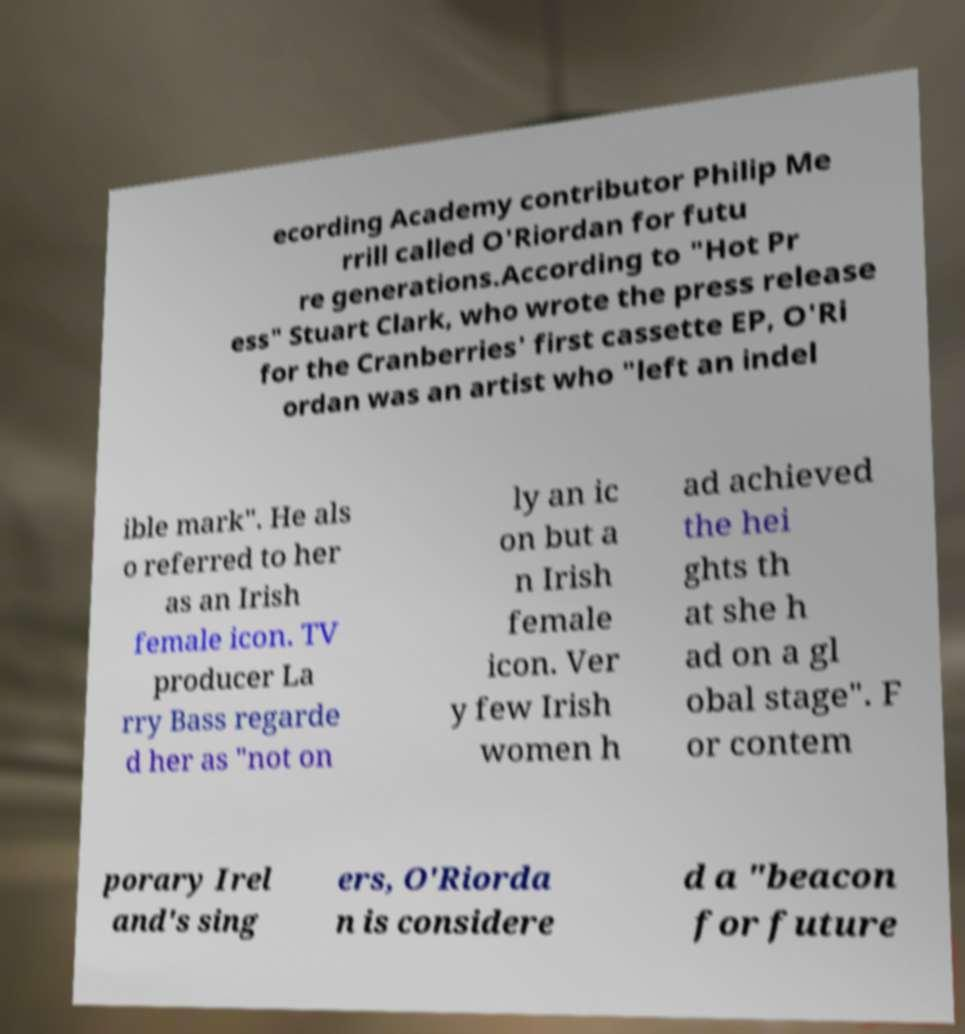Could you extract and type out the text from this image? ecording Academy contributor Philip Me rrill called O'Riordan for futu re generations.According to "Hot Pr ess" Stuart Clark, who wrote the press release for the Cranberries' first cassette EP, O'Ri ordan was an artist who "left an indel ible mark". He als o referred to her as an Irish female icon. TV producer La rry Bass regarde d her as "not on ly an ic on but a n Irish female icon. Ver y few Irish women h ad achieved the hei ghts th at she h ad on a gl obal stage". F or contem porary Irel and's sing ers, O'Riorda n is considere d a "beacon for future 